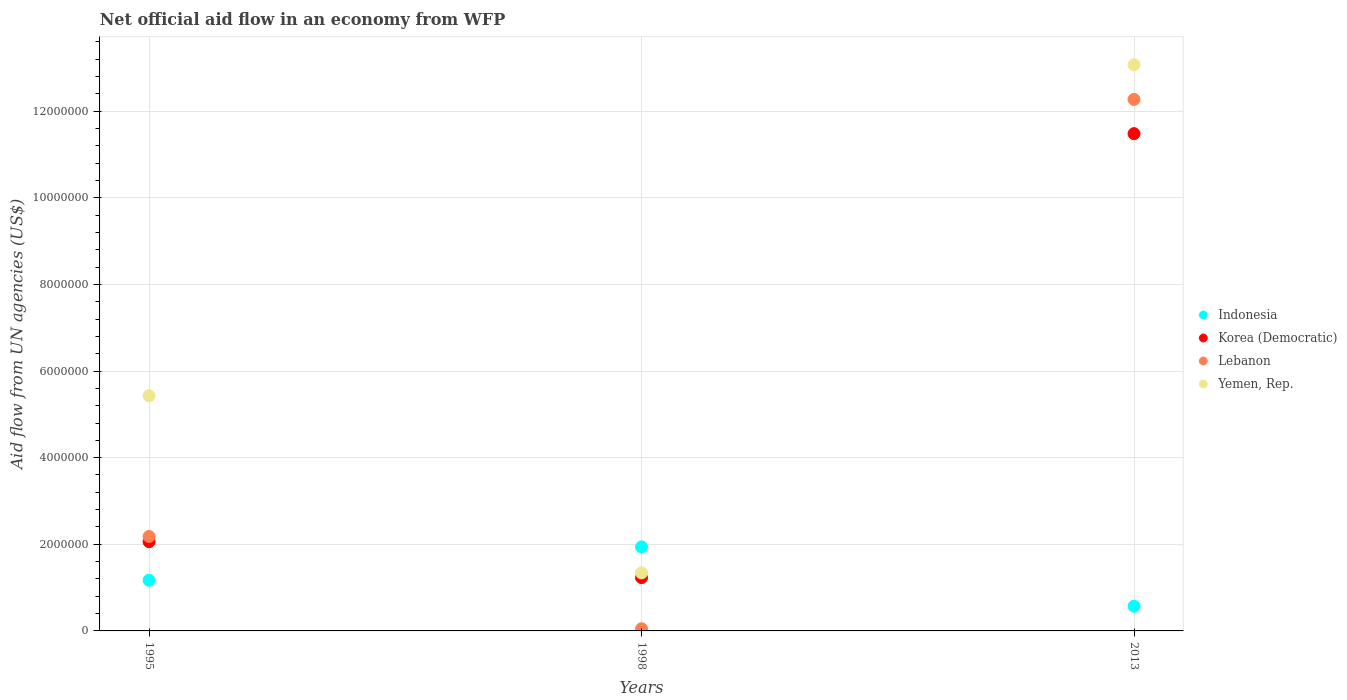How many different coloured dotlines are there?
Your answer should be compact. 4. What is the net official aid flow in Korea (Democratic) in 2013?
Provide a succinct answer. 1.15e+07. Across all years, what is the maximum net official aid flow in Indonesia?
Give a very brief answer. 1.94e+06. Across all years, what is the minimum net official aid flow in Indonesia?
Make the answer very short. 5.70e+05. In which year was the net official aid flow in Indonesia maximum?
Ensure brevity in your answer.  1998. In which year was the net official aid flow in Yemen, Rep. minimum?
Ensure brevity in your answer.  1998. What is the total net official aid flow in Indonesia in the graph?
Offer a very short reply. 3.68e+06. What is the difference between the net official aid flow in Lebanon in 1995 and that in 1998?
Provide a succinct answer. 2.13e+06. What is the difference between the net official aid flow in Indonesia in 1998 and the net official aid flow in Yemen, Rep. in 1995?
Offer a very short reply. -3.49e+06. What is the average net official aid flow in Lebanon per year?
Provide a succinct answer. 4.83e+06. In the year 2013, what is the difference between the net official aid flow in Korea (Democratic) and net official aid flow in Lebanon?
Your response must be concise. -7.90e+05. What is the ratio of the net official aid flow in Lebanon in 1995 to that in 1998?
Provide a short and direct response. 43.6. Is the net official aid flow in Lebanon in 1998 less than that in 2013?
Make the answer very short. Yes. What is the difference between the highest and the second highest net official aid flow in Lebanon?
Offer a terse response. 1.01e+07. What is the difference between the highest and the lowest net official aid flow in Lebanon?
Offer a terse response. 1.22e+07. Is the sum of the net official aid flow in Indonesia in 1995 and 1998 greater than the maximum net official aid flow in Korea (Democratic) across all years?
Offer a terse response. No. Is it the case that in every year, the sum of the net official aid flow in Indonesia and net official aid flow in Yemen, Rep.  is greater than the sum of net official aid flow in Korea (Democratic) and net official aid flow in Lebanon?
Offer a terse response. No. Does the net official aid flow in Yemen, Rep. monotonically increase over the years?
Give a very brief answer. No. Is the net official aid flow in Indonesia strictly less than the net official aid flow in Yemen, Rep. over the years?
Give a very brief answer. No. How many dotlines are there?
Ensure brevity in your answer.  4. How many years are there in the graph?
Offer a very short reply. 3. What is the difference between two consecutive major ticks on the Y-axis?
Keep it short and to the point. 2.00e+06. What is the title of the graph?
Provide a short and direct response. Net official aid flow in an economy from WFP. Does "Congo (Republic)" appear as one of the legend labels in the graph?
Keep it short and to the point. No. What is the label or title of the X-axis?
Provide a succinct answer. Years. What is the label or title of the Y-axis?
Offer a terse response. Aid flow from UN agencies (US$). What is the Aid flow from UN agencies (US$) of Indonesia in 1995?
Give a very brief answer. 1.17e+06. What is the Aid flow from UN agencies (US$) of Korea (Democratic) in 1995?
Your answer should be very brief. 2.06e+06. What is the Aid flow from UN agencies (US$) in Lebanon in 1995?
Your response must be concise. 2.18e+06. What is the Aid flow from UN agencies (US$) in Yemen, Rep. in 1995?
Provide a succinct answer. 5.43e+06. What is the Aid flow from UN agencies (US$) in Indonesia in 1998?
Your response must be concise. 1.94e+06. What is the Aid flow from UN agencies (US$) in Korea (Democratic) in 1998?
Your response must be concise. 1.23e+06. What is the Aid flow from UN agencies (US$) in Yemen, Rep. in 1998?
Make the answer very short. 1.34e+06. What is the Aid flow from UN agencies (US$) of Indonesia in 2013?
Ensure brevity in your answer.  5.70e+05. What is the Aid flow from UN agencies (US$) in Korea (Democratic) in 2013?
Offer a terse response. 1.15e+07. What is the Aid flow from UN agencies (US$) in Lebanon in 2013?
Keep it short and to the point. 1.23e+07. What is the Aid flow from UN agencies (US$) of Yemen, Rep. in 2013?
Make the answer very short. 1.31e+07. Across all years, what is the maximum Aid flow from UN agencies (US$) in Indonesia?
Your answer should be compact. 1.94e+06. Across all years, what is the maximum Aid flow from UN agencies (US$) in Korea (Democratic)?
Keep it short and to the point. 1.15e+07. Across all years, what is the maximum Aid flow from UN agencies (US$) in Lebanon?
Make the answer very short. 1.23e+07. Across all years, what is the maximum Aid flow from UN agencies (US$) in Yemen, Rep.?
Provide a succinct answer. 1.31e+07. Across all years, what is the minimum Aid flow from UN agencies (US$) in Indonesia?
Your answer should be very brief. 5.70e+05. Across all years, what is the minimum Aid flow from UN agencies (US$) in Korea (Democratic)?
Offer a terse response. 1.23e+06. Across all years, what is the minimum Aid flow from UN agencies (US$) of Yemen, Rep.?
Give a very brief answer. 1.34e+06. What is the total Aid flow from UN agencies (US$) of Indonesia in the graph?
Offer a very short reply. 3.68e+06. What is the total Aid flow from UN agencies (US$) of Korea (Democratic) in the graph?
Make the answer very short. 1.48e+07. What is the total Aid flow from UN agencies (US$) in Lebanon in the graph?
Offer a terse response. 1.45e+07. What is the total Aid flow from UN agencies (US$) of Yemen, Rep. in the graph?
Keep it short and to the point. 1.98e+07. What is the difference between the Aid flow from UN agencies (US$) in Indonesia in 1995 and that in 1998?
Provide a short and direct response. -7.70e+05. What is the difference between the Aid flow from UN agencies (US$) of Korea (Democratic) in 1995 and that in 1998?
Ensure brevity in your answer.  8.30e+05. What is the difference between the Aid flow from UN agencies (US$) of Lebanon in 1995 and that in 1998?
Provide a short and direct response. 2.13e+06. What is the difference between the Aid flow from UN agencies (US$) in Yemen, Rep. in 1995 and that in 1998?
Give a very brief answer. 4.09e+06. What is the difference between the Aid flow from UN agencies (US$) of Indonesia in 1995 and that in 2013?
Make the answer very short. 6.00e+05. What is the difference between the Aid flow from UN agencies (US$) of Korea (Democratic) in 1995 and that in 2013?
Make the answer very short. -9.42e+06. What is the difference between the Aid flow from UN agencies (US$) of Lebanon in 1995 and that in 2013?
Your answer should be very brief. -1.01e+07. What is the difference between the Aid flow from UN agencies (US$) in Yemen, Rep. in 1995 and that in 2013?
Provide a succinct answer. -7.64e+06. What is the difference between the Aid flow from UN agencies (US$) in Indonesia in 1998 and that in 2013?
Your response must be concise. 1.37e+06. What is the difference between the Aid flow from UN agencies (US$) of Korea (Democratic) in 1998 and that in 2013?
Provide a short and direct response. -1.02e+07. What is the difference between the Aid flow from UN agencies (US$) of Lebanon in 1998 and that in 2013?
Offer a terse response. -1.22e+07. What is the difference between the Aid flow from UN agencies (US$) in Yemen, Rep. in 1998 and that in 2013?
Your response must be concise. -1.17e+07. What is the difference between the Aid flow from UN agencies (US$) in Indonesia in 1995 and the Aid flow from UN agencies (US$) in Korea (Democratic) in 1998?
Ensure brevity in your answer.  -6.00e+04. What is the difference between the Aid flow from UN agencies (US$) in Indonesia in 1995 and the Aid flow from UN agencies (US$) in Lebanon in 1998?
Offer a very short reply. 1.12e+06. What is the difference between the Aid flow from UN agencies (US$) of Korea (Democratic) in 1995 and the Aid flow from UN agencies (US$) of Lebanon in 1998?
Your response must be concise. 2.01e+06. What is the difference between the Aid flow from UN agencies (US$) in Korea (Democratic) in 1995 and the Aid flow from UN agencies (US$) in Yemen, Rep. in 1998?
Provide a short and direct response. 7.20e+05. What is the difference between the Aid flow from UN agencies (US$) of Lebanon in 1995 and the Aid flow from UN agencies (US$) of Yemen, Rep. in 1998?
Give a very brief answer. 8.40e+05. What is the difference between the Aid flow from UN agencies (US$) in Indonesia in 1995 and the Aid flow from UN agencies (US$) in Korea (Democratic) in 2013?
Keep it short and to the point. -1.03e+07. What is the difference between the Aid flow from UN agencies (US$) in Indonesia in 1995 and the Aid flow from UN agencies (US$) in Lebanon in 2013?
Your answer should be very brief. -1.11e+07. What is the difference between the Aid flow from UN agencies (US$) in Indonesia in 1995 and the Aid flow from UN agencies (US$) in Yemen, Rep. in 2013?
Keep it short and to the point. -1.19e+07. What is the difference between the Aid flow from UN agencies (US$) of Korea (Democratic) in 1995 and the Aid flow from UN agencies (US$) of Lebanon in 2013?
Keep it short and to the point. -1.02e+07. What is the difference between the Aid flow from UN agencies (US$) of Korea (Democratic) in 1995 and the Aid flow from UN agencies (US$) of Yemen, Rep. in 2013?
Make the answer very short. -1.10e+07. What is the difference between the Aid flow from UN agencies (US$) in Lebanon in 1995 and the Aid flow from UN agencies (US$) in Yemen, Rep. in 2013?
Your answer should be very brief. -1.09e+07. What is the difference between the Aid flow from UN agencies (US$) in Indonesia in 1998 and the Aid flow from UN agencies (US$) in Korea (Democratic) in 2013?
Keep it short and to the point. -9.54e+06. What is the difference between the Aid flow from UN agencies (US$) of Indonesia in 1998 and the Aid flow from UN agencies (US$) of Lebanon in 2013?
Make the answer very short. -1.03e+07. What is the difference between the Aid flow from UN agencies (US$) of Indonesia in 1998 and the Aid flow from UN agencies (US$) of Yemen, Rep. in 2013?
Your answer should be compact. -1.11e+07. What is the difference between the Aid flow from UN agencies (US$) in Korea (Democratic) in 1998 and the Aid flow from UN agencies (US$) in Lebanon in 2013?
Ensure brevity in your answer.  -1.10e+07. What is the difference between the Aid flow from UN agencies (US$) in Korea (Democratic) in 1998 and the Aid flow from UN agencies (US$) in Yemen, Rep. in 2013?
Make the answer very short. -1.18e+07. What is the difference between the Aid flow from UN agencies (US$) in Lebanon in 1998 and the Aid flow from UN agencies (US$) in Yemen, Rep. in 2013?
Your answer should be very brief. -1.30e+07. What is the average Aid flow from UN agencies (US$) in Indonesia per year?
Provide a short and direct response. 1.23e+06. What is the average Aid flow from UN agencies (US$) in Korea (Democratic) per year?
Give a very brief answer. 4.92e+06. What is the average Aid flow from UN agencies (US$) of Lebanon per year?
Provide a short and direct response. 4.83e+06. What is the average Aid flow from UN agencies (US$) in Yemen, Rep. per year?
Your answer should be very brief. 6.61e+06. In the year 1995, what is the difference between the Aid flow from UN agencies (US$) of Indonesia and Aid flow from UN agencies (US$) of Korea (Democratic)?
Your response must be concise. -8.90e+05. In the year 1995, what is the difference between the Aid flow from UN agencies (US$) in Indonesia and Aid flow from UN agencies (US$) in Lebanon?
Provide a short and direct response. -1.01e+06. In the year 1995, what is the difference between the Aid flow from UN agencies (US$) of Indonesia and Aid flow from UN agencies (US$) of Yemen, Rep.?
Offer a terse response. -4.26e+06. In the year 1995, what is the difference between the Aid flow from UN agencies (US$) in Korea (Democratic) and Aid flow from UN agencies (US$) in Yemen, Rep.?
Give a very brief answer. -3.37e+06. In the year 1995, what is the difference between the Aid flow from UN agencies (US$) in Lebanon and Aid flow from UN agencies (US$) in Yemen, Rep.?
Make the answer very short. -3.25e+06. In the year 1998, what is the difference between the Aid flow from UN agencies (US$) of Indonesia and Aid flow from UN agencies (US$) of Korea (Democratic)?
Provide a succinct answer. 7.10e+05. In the year 1998, what is the difference between the Aid flow from UN agencies (US$) in Indonesia and Aid flow from UN agencies (US$) in Lebanon?
Your response must be concise. 1.89e+06. In the year 1998, what is the difference between the Aid flow from UN agencies (US$) in Indonesia and Aid flow from UN agencies (US$) in Yemen, Rep.?
Make the answer very short. 6.00e+05. In the year 1998, what is the difference between the Aid flow from UN agencies (US$) of Korea (Democratic) and Aid flow from UN agencies (US$) of Lebanon?
Your answer should be compact. 1.18e+06. In the year 1998, what is the difference between the Aid flow from UN agencies (US$) of Lebanon and Aid flow from UN agencies (US$) of Yemen, Rep.?
Offer a terse response. -1.29e+06. In the year 2013, what is the difference between the Aid flow from UN agencies (US$) of Indonesia and Aid flow from UN agencies (US$) of Korea (Democratic)?
Your answer should be compact. -1.09e+07. In the year 2013, what is the difference between the Aid flow from UN agencies (US$) of Indonesia and Aid flow from UN agencies (US$) of Lebanon?
Your answer should be very brief. -1.17e+07. In the year 2013, what is the difference between the Aid flow from UN agencies (US$) of Indonesia and Aid flow from UN agencies (US$) of Yemen, Rep.?
Provide a short and direct response. -1.25e+07. In the year 2013, what is the difference between the Aid flow from UN agencies (US$) in Korea (Democratic) and Aid flow from UN agencies (US$) in Lebanon?
Your answer should be compact. -7.90e+05. In the year 2013, what is the difference between the Aid flow from UN agencies (US$) in Korea (Democratic) and Aid flow from UN agencies (US$) in Yemen, Rep.?
Your answer should be very brief. -1.59e+06. In the year 2013, what is the difference between the Aid flow from UN agencies (US$) of Lebanon and Aid flow from UN agencies (US$) of Yemen, Rep.?
Make the answer very short. -8.00e+05. What is the ratio of the Aid flow from UN agencies (US$) in Indonesia in 1995 to that in 1998?
Offer a terse response. 0.6. What is the ratio of the Aid flow from UN agencies (US$) of Korea (Democratic) in 1995 to that in 1998?
Offer a very short reply. 1.67. What is the ratio of the Aid flow from UN agencies (US$) of Lebanon in 1995 to that in 1998?
Offer a very short reply. 43.6. What is the ratio of the Aid flow from UN agencies (US$) in Yemen, Rep. in 1995 to that in 1998?
Your answer should be compact. 4.05. What is the ratio of the Aid flow from UN agencies (US$) of Indonesia in 1995 to that in 2013?
Make the answer very short. 2.05. What is the ratio of the Aid flow from UN agencies (US$) in Korea (Democratic) in 1995 to that in 2013?
Offer a terse response. 0.18. What is the ratio of the Aid flow from UN agencies (US$) of Lebanon in 1995 to that in 2013?
Offer a very short reply. 0.18. What is the ratio of the Aid flow from UN agencies (US$) in Yemen, Rep. in 1995 to that in 2013?
Your response must be concise. 0.42. What is the ratio of the Aid flow from UN agencies (US$) of Indonesia in 1998 to that in 2013?
Keep it short and to the point. 3.4. What is the ratio of the Aid flow from UN agencies (US$) in Korea (Democratic) in 1998 to that in 2013?
Provide a short and direct response. 0.11. What is the ratio of the Aid flow from UN agencies (US$) in Lebanon in 1998 to that in 2013?
Provide a succinct answer. 0. What is the ratio of the Aid flow from UN agencies (US$) in Yemen, Rep. in 1998 to that in 2013?
Offer a terse response. 0.1. What is the difference between the highest and the second highest Aid flow from UN agencies (US$) in Indonesia?
Provide a succinct answer. 7.70e+05. What is the difference between the highest and the second highest Aid flow from UN agencies (US$) of Korea (Democratic)?
Ensure brevity in your answer.  9.42e+06. What is the difference between the highest and the second highest Aid flow from UN agencies (US$) in Lebanon?
Give a very brief answer. 1.01e+07. What is the difference between the highest and the second highest Aid flow from UN agencies (US$) of Yemen, Rep.?
Ensure brevity in your answer.  7.64e+06. What is the difference between the highest and the lowest Aid flow from UN agencies (US$) in Indonesia?
Offer a very short reply. 1.37e+06. What is the difference between the highest and the lowest Aid flow from UN agencies (US$) in Korea (Democratic)?
Keep it short and to the point. 1.02e+07. What is the difference between the highest and the lowest Aid flow from UN agencies (US$) in Lebanon?
Provide a short and direct response. 1.22e+07. What is the difference between the highest and the lowest Aid flow from UN agencies (US$) in Yemen, Rep.?
Your response must be concise. 1.17e+07. 